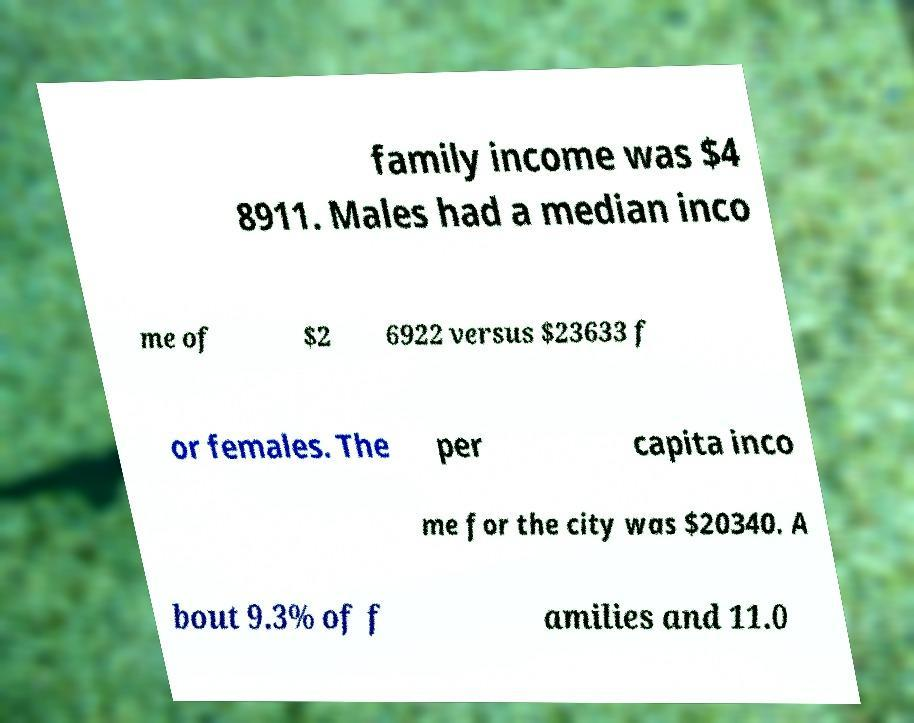Can you accurately transcribe the text from the provided image for me? family income was $4 8911. Males had a median inco me of $2 6922 versus $23633 f or females. The per capita inco me for the city was $20340. A bout 9.3% of f amilies and 11.0 